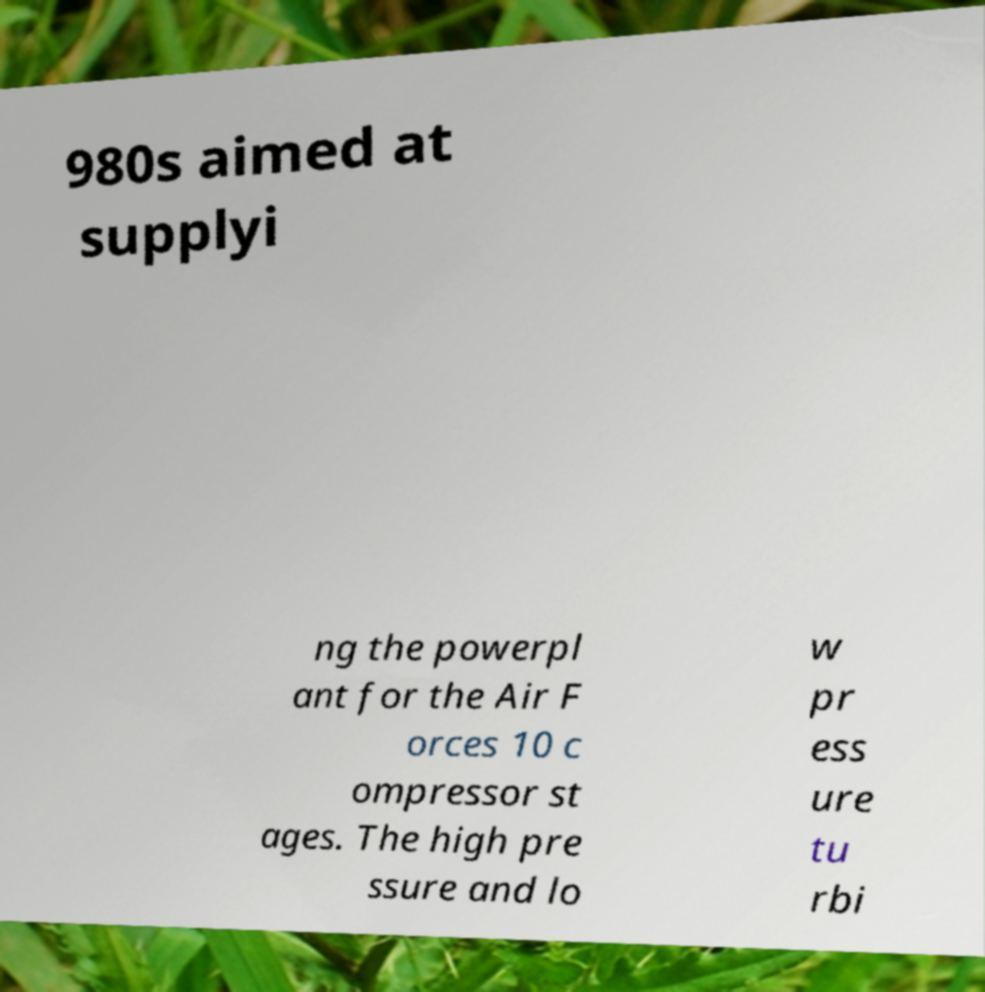Can you accurately transcribe the text from the provided image for me? 980s aimed at supplyi ng the powerpl ant for the Air F orces 10 c ompressor st ages. The high pre ssure and lo w pr ess ure tu rbi 